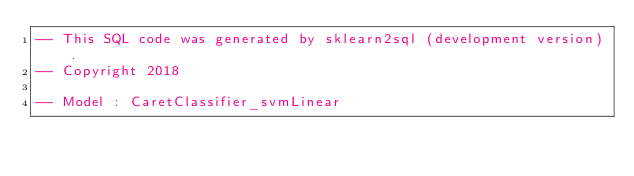Convert code to text. <code><loc_0><loc_0><loc_500><loc_500><_SQL_>-- This SQL code was generated by sklearn2sql (development version).
-- Copyright 2018

-- Model : CaretClassifier_svmLinear</code> 